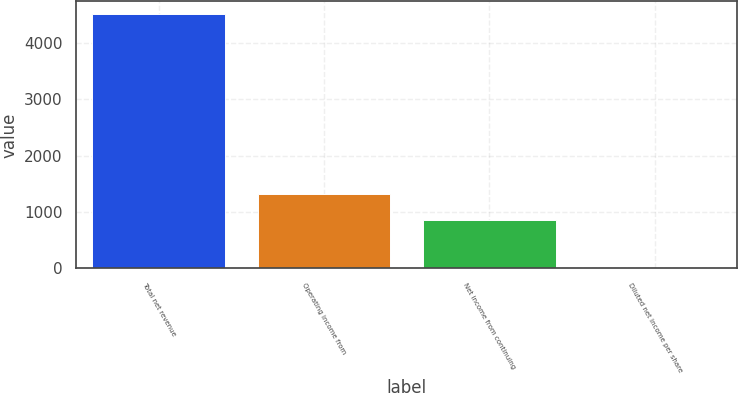Convert chart to OTSL. <chart><loc_0><loc_0><loc_500><loc_500><bar_chart><fcel>Total net revenue<fcel>Operating income from<fcel>Net income from continuing<fcel>Diluted net income per share<nl><fcel>4506<fcel>1314<fcel>861<fcel>2.96<nl></chart> 